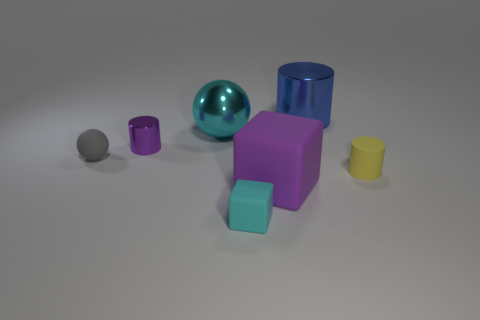Subtract all tiny yellow matte cylinders. How many cylinders are left? 2 Subtract all gray balls. How many balls are left? 1 Add 1 large things. How many objects exist? 8 Subtract all spheres. How many objects are left? 5 Subtract 1 spheres. How many spheres are left? 1 Subtract all yellow balls. Subtract all gray blocks. How many balls are left? 2 Subtract all red cubes. How many purple cylinders are left? 1 Subtract all shiny objects. Subtract all large blue shiny blocks. How many objects are left? 4 Add 2 tiny cyan things. How many tiny cyan things are left? 3 Add 6 metallic objects. How many metallic objects exist? 9 